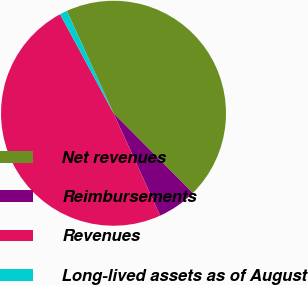<chart> <loc_0><loc_0><loc_500><loc_500><pie_chart><fcel>Net revenues<fcel>Reimbursements<fcel>Revenues<fcel>Long-lived assets as of August<nl><fcel>44.35%<fcel>5.65%<fcel>48.93%<fcel>1.07%<nl></chart> 